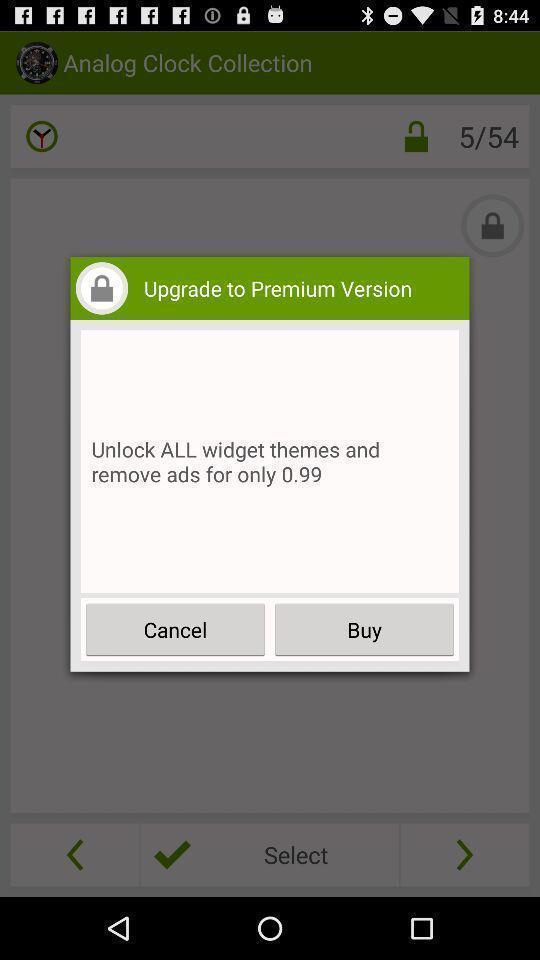Explain the elements present in this screenshot. Pop up window asking to upgrade. 